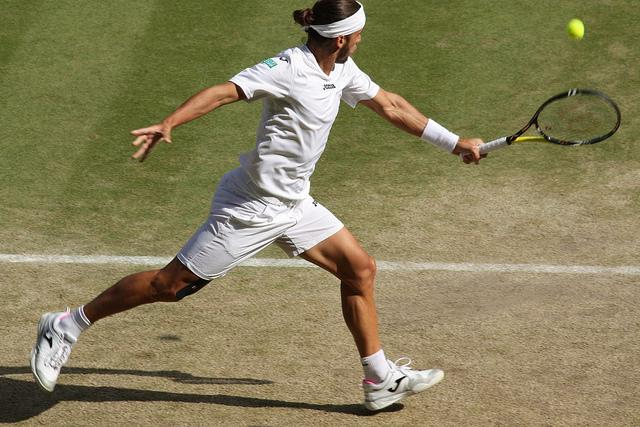What is in the man's hand? Please explain your reasoning. tennis racquet. He is holding a tennis raquet. 